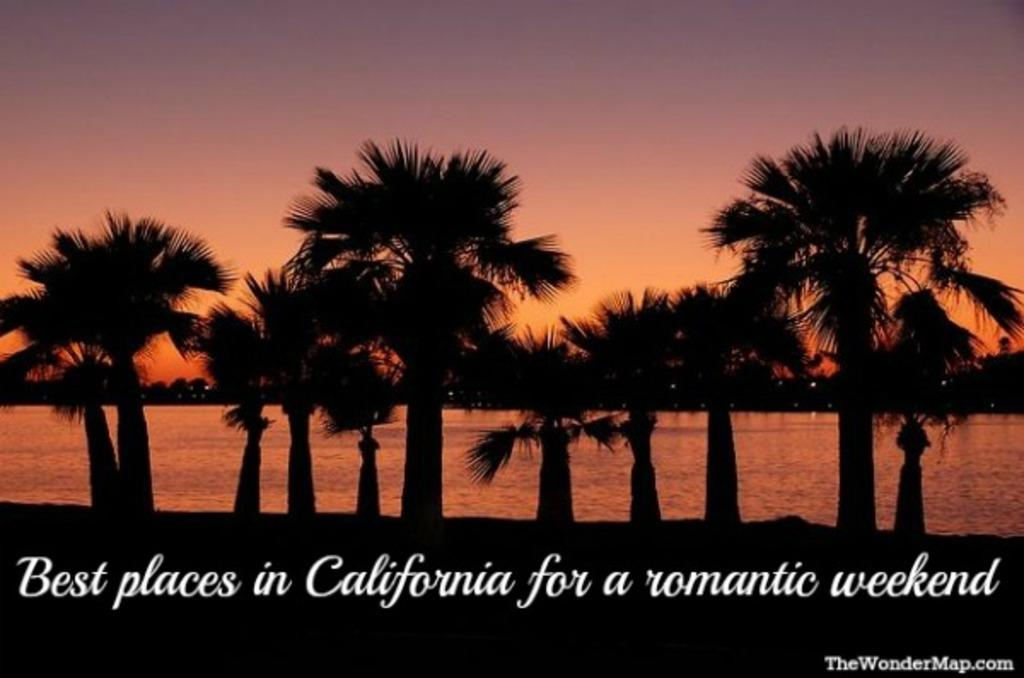What is the main feature in the foreground of the image? There are many trees in the foreground of the image. What can be seen in the background of the image? The background of the image is the sky. How many buttons can be seen on the trees in the image? There are no buttons present on the trees in the image, as buttons are not a natural part of trees. What type of beetle can be seen crawling on the sky in the image? There are no beetles present on the sky in the image, as beetles are not capable of crawling on the sky. 